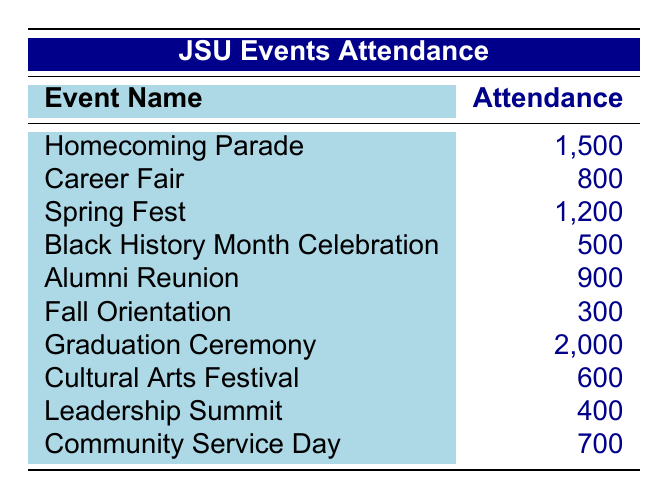What's the highest attendance at an event? The table shows various events with their attendance numbers. To find the highest, we look through the attendance column and find that the Graduation Ceremony has the highest attendance of 2000.
Answer: 2000 What is the attendance for the Homecoming Parade? The table lists the Homecoming Parade's attendance, which is clearly stated as 1500.
Answer: 1500 How many events had an attendance of 700 or more? By examining the attendance numbers, we find that five events (Homecoming Parade, Graduation Ceremony, Spring Fest, Alumni Reunion, and Community Service Day) had an attendance of 700 or more.
Answer: 5 What is the average attendance of all events listed? We sum up the attendance numbers (1500 + 800 + 1200 + 500 + 900 + 300 + 2000 + 600 + 400 + 700 = 8100) and divide by the number of events (10). The average attendance is 8100/10 = 810.
Answer: 810 Did the Cultural Arts Festival have more than 650 attendees? The Cultural Arts Festival has an attendance of 600, which is less than 650. Therefore, the statement is false.
Answer: No Which event had the lowest attendance? By examining the attendance numbers, we see that Fall Orientation has the lowest attendance at 300.
Answer: Fall Orientation What is the difference in attendance between the Graduation Ceremony and the Community Service Day? The attendance for the Graduation Ceremony is 2000 and for the Community Service Day is 700. To find the difference, we subtract 700 from 2000, which gives us 1300.
Answer: 1300 Is the attendance at the Leadership Summit greater than that of the Black History Month Celebration? The attendance for the Leadership Summit is 400, and for the Black History Month Celebration, it is 500. Since 400 is less than 500, the statement is false.
Answer: No What is the total attendance for the Spring Fest and the Alumni Reunion combined? The attendance for Spring Fest is 1200 and for the Alumni Reunion, it is 900. By adding these together (1200 + 900), we get a total of 2100.
Answer: 2100 